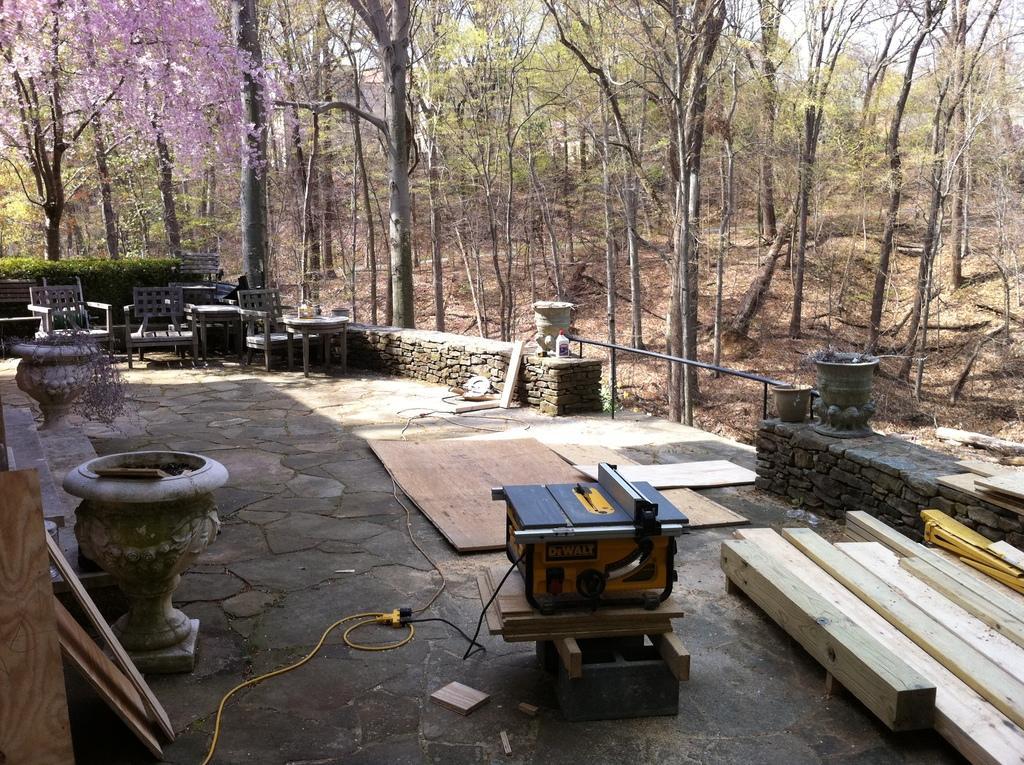In one or two sentences, can you explain what this image depicts? In the picture we can see a forest are with a path with tiles on it we can see some chairs, wooden planks, and cutting machines and around the path we can see wall and behind it we can see full of trees. 